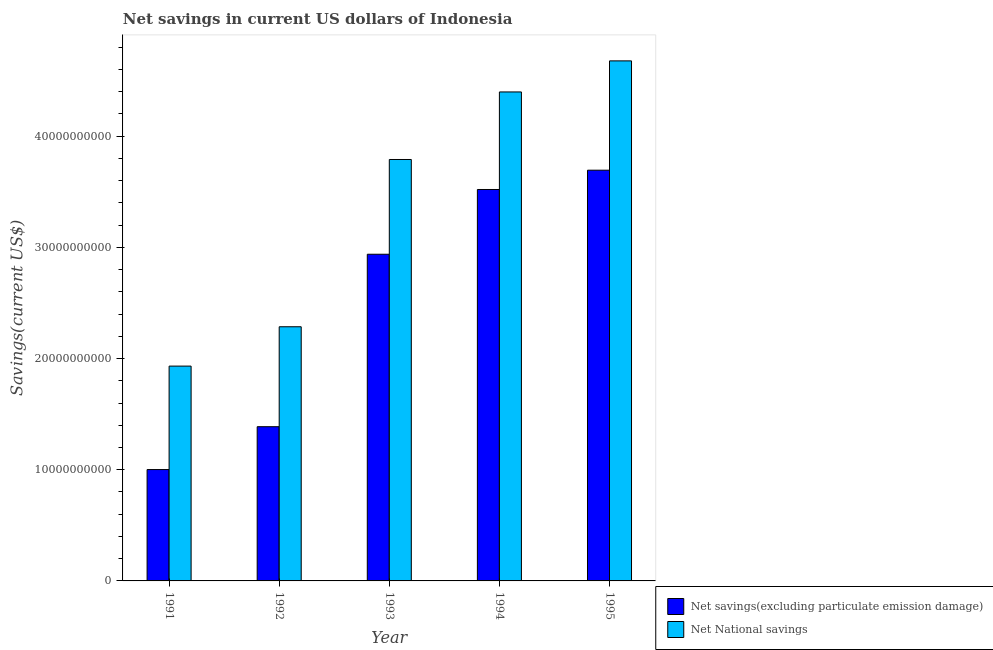Are the number of bars per tick equal to the number of legend labels?
Provide a succinct answer. Yes. In how many cases, is the number of bars for a given year not equal to the number of legend labels?
Offer a terse response. 0. What is the net savings(excluding particulate emission damage) in 1991?
Provide a succinct answer. 1.00e+1. Across all years, what is the maximum net savings(excluding particulate emission damage)?
Offer a terse response. 3.69e+1. Across all years, what is the minimum net national savings?
Your answer should be very brief. 1.93e+1. In which year was the net savings(excluding particulate emission damage) maximum?
Your answer should be compact. 1995. What is the total net savings(excluding particulate emission damage) in the graph?
Offer a terse response. 1.25e+11. What is the difference between the net national savings in 1991 and that in 1995?
Your response must be concise. -2.74e+1. What is the difference between the net savings(excluding particulate emission damage) in 1994 and the net national savings in 1995?
Ensure brevity in your answer.  -1.74e+09. What is the average net savings(excluding particulate emission damage) per year?
Ensure brevity in your answer.  2.51e+1. In the year 1994, what is the difference between the net national savings and net savings(excluding particulate emission damage)?
Give a very brief answer. 0. In how many years, is the net savings(excluding particulate emission damage) greater than 28000000000 US$?
Provide a succinct answer. 3. What is the ratio of the net national savings in 1993 to that in 1995?
Your response must be concise. 0.81. Is the net national savings in 1994 less than that in 1995?
Offer a very short reply. Yes. Is the difference between the net savings(excluding particulate emission damage) in 1992 and 1993 greater than the difference between the net national savings in 1992 and 1993?
Your response must be concise. No. What is the difference between the highest and the second highest net national savings?
Your answer should be very brief. 2.79e+09. What is the difference between the highest and the lowest net national savings?
Keep it short and to the point. 2.74e+1. In how many years, is the net savings(excluding particulate emission damage) greater than the average net savings(excluding particulate emission damage) taken over all years?
Ensure brevity in your answer.  3. What does the 1st bar from the left in 1993 represents?
Your answer should be compact. Net savings(excluding particulate emission damage). What does the 1st bar from the right in 1995 represents?
Your answer should be compact. Net National savings. How many bars are there?
Your answer should be very brief. 10. What is the difference between two consecutive major ticks on the Y-axis?
Give a very brief answer. 1.00e+1. Are the values on the major ticks of Y-axis written in scientific E-notation?
Make the answer very short. No. Does the graph contain any zero values?
Offer a terse response. No. Does the graph contain grids?
Keep it short and to the point. No. Where does the legend appear in the graph?
Your response must be concise. Bottom right. How many legend labels are there?
Keep it short and to the point. 2. What is the title of the graph?
Your response must be concise. Net savings in current US dollars of Indonesia. What is the label or title of the X-axis?
Provide a short and direct response. Year. What is the label or title of the Y-axis?
Keep it short and to the point. Savings(current US$). What is the Savings(current US$) in Net savings(excluding particulate emission damage) in 1991?
Offer a terse response. 1.00e+1. What is the Savings(current US$) in Net National savings in 1991?
Your answer should be very brief. 1.93e+1. What is the Savings(current US$) of Net savings(excluding particulate emission damage) in 1992?
Provide a succinct answer. 1.39e+1. What is the Savings(current US$) in Net National savings in 1992?
Make the answer very short. 2.29e+1. What is the Savings(current US$) of Net savings(excluding particulate emission damage) in 1993?
Provide a succinct answer. 2.94e+1. What is the Savings(current US$) of Net National savings in 1993?
Your response must be concise. 3.79e+1. What is the Savings(current US$) of Net savings(excluding particulate emission damage) in 1994?
Offer a very short reply. 3.52e+1. What is the Savings(current US$) of Net National savings in 1994?
Give a very brief answer. 4.40e+1. What is the Savings(current US$) of Net savings(excluding particulate emission damage) in 1995?
Provide a succinct answer. 3.69e+1. What is the Savings(current US$) of Net National savings in 1995?
Your response must be concise. 4.68e+1. Across all years, what is the maximum Savings(current US$) of Net savings(excluding particulate emission damage)?
Give a very brief answer. 3.69e+1. Across all years, what is the maximum Savings(current US$) in Net National savings?
Your response must be concise. 4.68e+1. Across all years, what is the minimum Savings(current US$) in Net savings(excluding particulate emission damage)?
Your answer should be very brief. 1.00e+1. Across all years, what is the minimum Savings(current US$) of Net National savings?
Your response must be concise. 1.93e+1. What is the total Savings(current US$) of Net savings(excluding particulate emission damage) in the graph?
Ensure brevity in your answer.  1.25e+11. What is the total Savings(current US$) of Net National savings in the graph?
Your response must be concise. 1.71e+11. What is the difference between the Savings(current US$) in Net savings(excluding particulate emission damage) in 1991 and that in 1992?
Provide a short and direct response. -3.86e+09. What is the difference between the Savings(current US$) of Net National savings in 1991 and that in 1992?
Your answer should be very brief. -3.54e+09. What is the difference between the Savings(current US$) of Net savings(excluding particulate emission damage) in 1991 and that in 1993?
Your answer should be compact. -1.94e+1. What is the difference between the Savings(current US$) in Net National savings in 1991 and that in 1993?
Give a very brief answer. -1.86e+1. What is the difference between the Savings(current US$) in Net savings(excluding particulate emission damage) in 1991 and that in 1994?
Provide a short and direct response. -2.52e+1. What is the difference between the Savings(current US$) of Net National savings in 1991 and that in 1994?
Provide a short and direct response. -2.47e+1. What is the difference between the Savings(current US$) in Net savings(excluding particulate emission damage) in 1991 and that in 1995?
Your answer should be very brief. -2.69e+1. What is the difference between the Savings(current US$) in Net National savings in 1991 and that in 1995?
Offer a very short reply. -2.74e+1. What is the difference between the Savings(current US$) of Net savings(excluding particulate emission damage) in 1992 and that in 1993?
Ensure brevity in your answer.  -1.55e+1. What is the difference between the Savings(current US$) of Net National savings in 1992 and that in 1993?
Make the answer very short. -1.50e+1. What is the difference between the Savings(current US$) of Net savings(excluding particulate emission damage) in 1992 and that in 1994?
Offer a very short reply. -2.13e+1. What is the difference between the Savings(current US$) of Net National savings in 1992 and that in 1994?
Ensure brevity in your answer.  -2.11e+1. What is the difference between the Savings(current US$) in Net savings(excluding particulate emission damage) in 1992 and that in 1995?
Your answer should be very brief. -2.31e+1. What is the difference between the Savings(current US$) of Net National savings in 1992 and that in 1995?
Your answer should be very brief. -2.39e+1. What is the difference between the Savings(current US$) in Net savings(excluding particulate emission damage) in 1993 and that in 1994?
Your answer should be very brief. -5.82e+09. What is the difference between the Savings(current US$) of Net National savings in 1993 and that in 1994?
Make the answer very short. -6.08e+09. What is the difference between the Savings(current US$) in Net savings(excluding particulate emission damage) in 1993 and that in 1995?
Your answer should be very brief. -7.56e+09. What is the difference between the Savings(current US$) of Net National savings in 1993 and that in 1995?
Ensure brevity in your answer.  -8.87e+09. What is the difference between the Savings(current US$) in Net savings(excluding particulate emission damage) in 1994 and that in 1995?
Keep it short and to the point. -1.74e+09. What is the difference between the Savings(current US$) in Net National savings in 1994 and that in 1995?
Your answer should be compact. -2.79e+09. What is the difference between the Savings(current US$) in Net savings(excluding particulate emission damage) in 1991 and the Savings(current US$) in Net National savings in 1992?
Your answer should be compact. -1.28e+1. What is the difference between the Savings(current US$) of Net savings(excluding particulate emission damage) in 1991 and the Savings(current US$) of Net National savings in 1993?
Make the answer very short. -2.79e+1. What is the difference between the Savings(current US$) in Net savings(excluding particulate emission damage) in 1991 and the Savings(current US$) in Net National savings in 1994?
Provide a short and direct response. -3.40e+1. What is the difference between the Savings(current US$) of Net savings(excluding particulate emission damage) in 1991 and the Savings(current US$) of Net National savings in 1995?
Give a very brief answer. -3.68e+1. What is the difference between the Savings(current US$) in Net savings(excluding particulate emission damage) in 1992 and the Savings(current US$) in Net National savings in 1993?
Your answer should be compact. -2.40e+1. What is the difference between the Savings(current US$) of Net savings(excluding particulate emission damage) in 1992 and the Savings(current US$) of Net National savings in 1994?
Provide a succinct answer. -3.01e+1. What is the difference between the Savings(current US$) of Net savings(excluding particulate emission damage) in 1992 and the Savings(current US$) of Net National savings in 1995?
Your answer should be very brief. -3.29e+1. What is the difference between the Savings(current US$) in Net savings(excluding particulate emission damage) in 1993 and the Savings(current US$) in Net National savings in 1994?
Give a very brief answer. -1.46e+1. What is the difference between the Savings(current US$) in Net savings(excluding particulate emission damage) in 1993 and the Savings(current US$) in Net National savings in 1995?
Offer a very short reply. -1.74e+1. What is the difference between the Savings(current US$) of Net savings(excluding particulate emission damage) in 1994 and the Savings(current US$) of Net National savings in 1995?
Provide a succinct answer. -1.16e+1. What is the average Savings(current US$) in Net savings(excluding particulate emission damage) per year?
Your answer should be very brief. 2.51e+1. What is the average Savings(current US$) in Net National savings per year?
Offer a very short reply. 3.42e+1. In the year 1991, what is the difference between the Savings(current US$) of Net savings(excluding particulate emission damage) and Savings(current US$) of Net National savings?
Your response must be concise. -9.30e+09. In the year 1992, what is the difference between the Savings(current US$) of Net savings(excluding particulate emission damage) and Savings(current US$) of Net National savings?
Make the answer very short. -8.99e+09. In the year 1993, what is the difference between the Savings(current US$) of Net savings(excluding particulate emission damage) and Savings(current US$) of Net National savings?
Give a very brief answer. -8.52e+09. In the year 1994, what is the difference between the Savings(current US$) in Net savings(excluding particulate emission damage) and Savings(current US$) in Net National savings?
Give a very brief answer. -8.77e+09. In the year 1995, what is the difference between the Savings(current US$) of Net savings(excluding particulate emission damage) and Savings(current US$) of Net National savings?
Give a very brief answer. -9.83e+09. What is the ratio of the Savings(current US$) of Net savings(excluding particulate emission damage) in 1991 to that in 1992?
Offer a terse response. 0.72. What is the ratio of the Savings(current US$) of Net National savings in 1991 to that in 1992?
Your answer should be very brief. 0.85. What is the ratio of the Savings(current US$) of Net savings(excluding particulate emission damage) in 1991 to that in 1993?
Ensure brevity in your answer.  0.34. What is the ratio of the Savings(current US$) of Net National savings in 1991 to that in 1993?
Provide a succinct answer. 0.51. What is the ratio of the Savings(current US$) in Net savings(excluding particulate emission damage) in 1991 to that in 1994?
Offer a very short reply. 0.28. What is the ratio of the Savings(current US$) of Net National savings in 1991 to that in 1994?
Ensure brevity in your answer.  0.44. What is the ratio of the Savings(current US$) in Net savings(excluding particulate emission damage) in 1991 to that in 1995?
Offer a terse response. 0.27. What is the ratio of the Savings(current US$) in Net National savings in 1991 to that in 1995?
Offer a very short reply. 0.41. What is the ratio of the Savings(current US$) of Net savings(excluding particulate emission damage) in 1992 to that in 1993?
Provide a succinct answer. 0.47. What is the ratio of the Savings(current US$) of Net National savings in 1992 to that in 1993?
Give a very brief answer. 0.6. What is the ratio of the Savings(current US$) of Net savings(excluding particulate emission damage) in 1992 to that in 1994?
Give a very brief answer. 0.39. What is the ratio of the Savings(current US$) of Net National savings in 1992 to that in 1994?
Ensure brevity in your answer.  0.52. What is the ratio of the Savings(current US$) of Net savings(excluding particulate emission damage) in 1992 to that in 1995?
Give a very brief answer. 0.38. What is the ratio of the Savings(current US$) in Net National savings in 1992 to that in 1995?
Your answer should be very brief. 0.49. What is the ratio of the Savings(current US$) of Net savings(excluding particulate emission damage) in 1993 to that in 1994?
Your answer should be compact. 0.83. What is the ratio of the Savings(current US$) in Net National savings in 1993 to that in 1994?
Provide a succinct answer. 0.86. What is the ratio of the Savings(current US$) in Net savings(excluding particulate emission damage) in 1993 to that in 1995?
Ensure brevity in your answer.  0.8. What is the ratio of the Savings(current US$) of Net National savings in 1993 to that in 1995?
Make the answer very short. 0.81. What is the ratio of the Savings(current US$) in Net savings(excluding particulate emission damage) in 1994 to that in 1995?
Ensure brevity in your answer.  0.95. What is the ratio of the Savings(current US$) of Net National savings in 1994 to that in 1995?
Your answer should be very brief. 0.94. What is the difference between the highest and the second highest Savings(current US$) of Net savings(excluding particulate emission damage)?
Give a very brief answer. 1.74e+09. What is the difference between the highest and the second highest Savings(current US$) in Net National savings?
Make the answer very short. 2.79e+09. What is the difference between the highest and the lowest Savings(current US$) of Net savings(excluding particulate emission damage)?
Offer a terse response. 2.69e+1. What is the difference between the highest and the lowest Savings(current US$) of Net National savings?
Your answer should be very brief. 2.74e+1. 